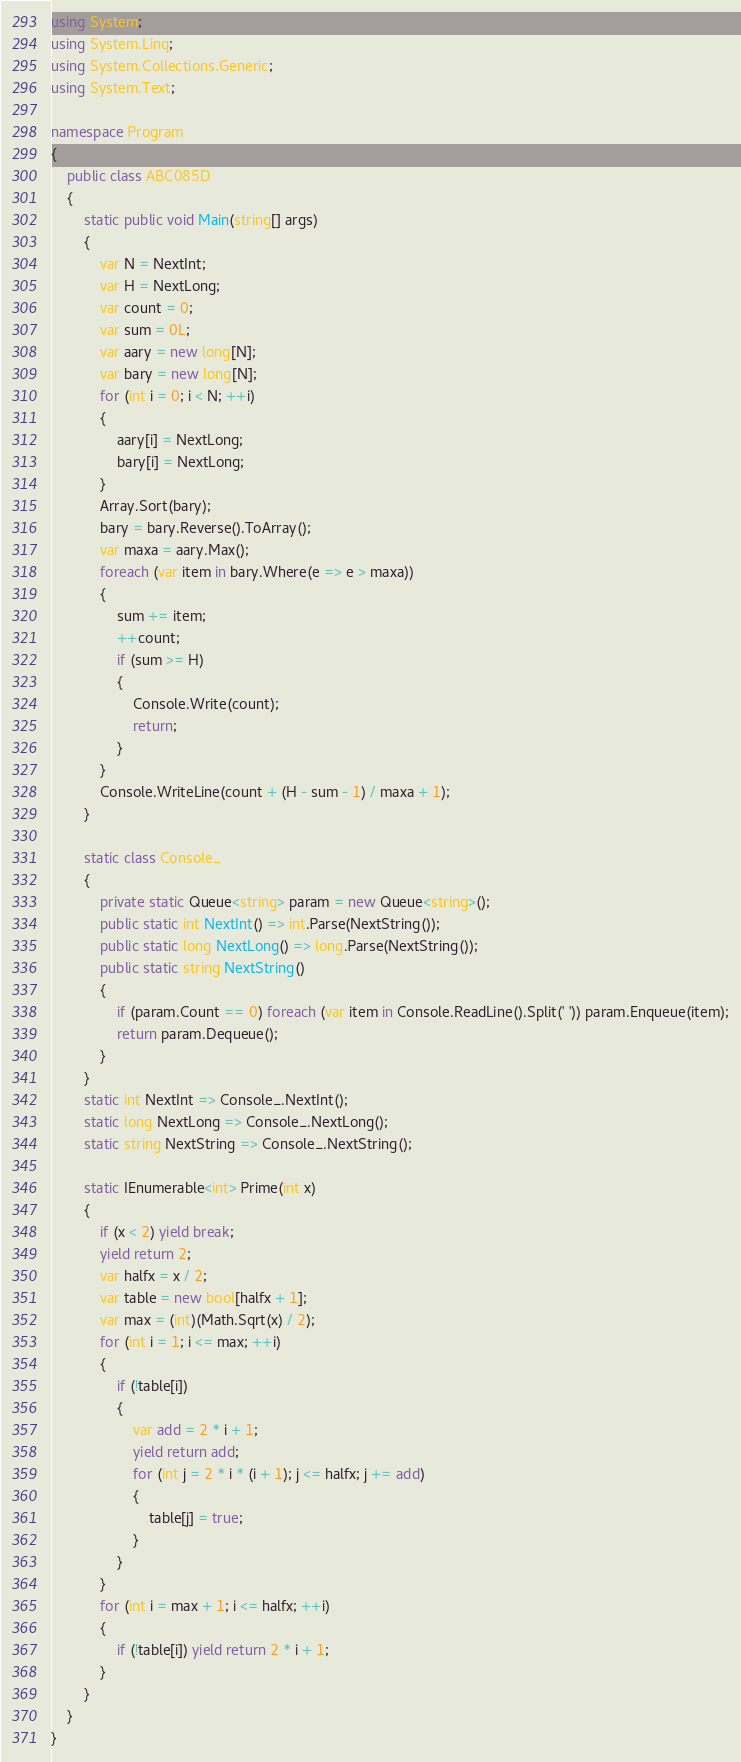Convert code to text. <code><loc_0><loc_0><loc_500><loc_500><_C#_>using System;
using System.Linq;
using System.Collections.Generic;
using System.Text;

namespace Program
{
    public class ABC085D
    {
        static public void Main(string[] args)
        {
            var N = NextInt;
            var H = NextLong;
            var count = 0;
            var sum = 0L;
            var aary = new long[N];
            var bary = new long[N];
            for (int i = 0; i < N; ++i)
            {
                aary[i] = NextLong;
                bary[i] = NextLong;
            }
            Array.Sort(bary);
            bary = bary.Reverse().ToArray();
            var maxa = aary.Max();
            foreach (var item in bary.Where(e => e > maxa))
            {
                sum += item;
                ++count;
                if (sum >= H)
                {
                    Console.Write(count);
                    return;
                }
            }
            Console.WriteLine(count + (H - sum - 1) / maxa + 1);
        }

        static class Console_
        {
            private static Queue<string> param = new Queue<string>();
            public static int NextInt() => int.Parse(NextString());
            public static long NextLong() => long.Parse(NextString());
            public static string NextString()
            {
                if (param.Count == 0) foreach (var item in Console.ReadLine().Split(' ')) param.Enqueue(item);
                return param.Dequeue();
            }
        }
        static int NextInt => Console_.NextInt();
        static long NextLong => Console_.NextLong();
        static string NextString => Console_.NextString();

        static IEnumerable<int> Prime(int x)
        {
            if (x < 2) yield break;
            yield return 2;
            var halfx = x / 2;
            var table = new bool[halfx + 1];
            var max = (int)(Math.Sqrt(x) / 2);
            for (int i = 1; i <= max; ++i)
            {
                if (!table[i])
                {
                    var add = 2 * i + 1;
                    yield return add;
                    for (int j = 2 * i * (i + 1); j <= halfx; j += add)
                    {
                        table[j] = true;
                    }
                }
            }
            for (int i = max + 1; i <= halfx; ++i)
            {
                if (!table[i]) yield return 2 * i + 1;
            }
        }
    }
}
</code> 